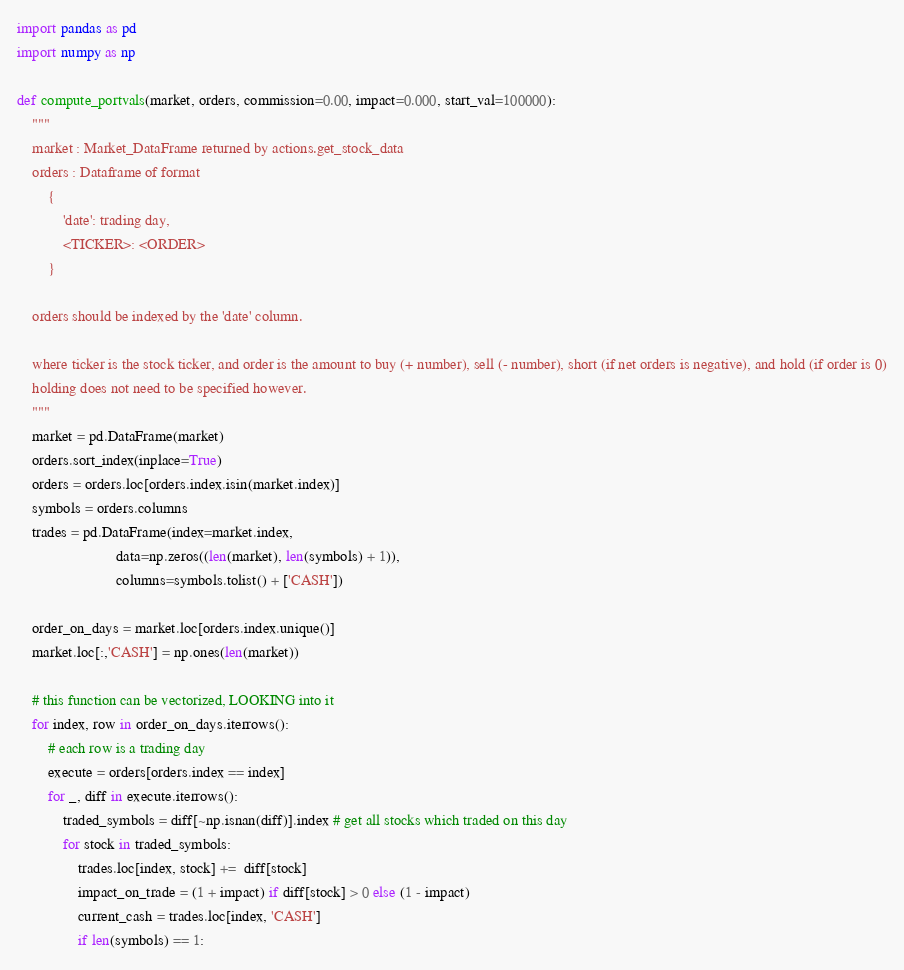Convert code to text. <code><loc_0><loc_0><loc_500><loc_500><_Python_>import pandas as pd
import numpy as np

def compute_portvals(market, orders, commission=0.00, impact=0.000, start_val=100000):
    """
    market : Market_DataFrame returned by actions.get_stock_data
    orders : Dataframe of format
        {
            'date': trading day,
            <TICKER>: <ORDER>
        }

    orders should be indexed by the 'date' column.

    where ticker is the stock ticker, and order is the amount to buy (+ number), sell (- number), short (if net orders is negative), and hold (if order is 0)
    holding does not need to be specified however.
    """
    market = pd.DataFrame(market)
    orders.sort_index(inplace=True)
    orders = orders.loc[orders.index.isin(market.index)]
    symbols = orders.columns
    trades = pd.DataFrame(index=market.index, 
                          data=np.zeros((len(market), len(symbols) + 1)), 
                          columns=symbols.tolist() + ['CASH'])
    
    order_on_days = market.loc[orders.index.unique()]
    market.loc[:,'CASH'] = np.ones(len(market))

    # this function can be vectorized, LOOKING into it
    for index, row in order_on_days.iterrows():
        # each row is a trading day
        execute = orders[orders.index == index]
        for _, diff in execute.iterrows():
            traded_symbols = diff[~np.isnan(diff)].index # get all stocks which traded on this day
            for stock in traded_symbols:
                trades.loc[index, stock] +=  diff[stock]
                impact_on_trade = (1 + impact) if diff[stock] > 0 else (1 - impact)
                current_cash = trades.loc[index, 'CASH']
                if len(symbols) == 1:</code> 